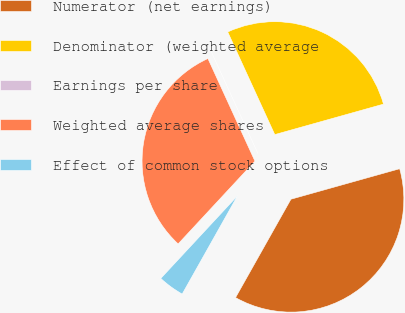<chart> <loc_0><loc_0><loc_500><loc_500><pie_chart><fcel>Numerator (net earnings)<fcel>Denominator (weighted average<fcel>Earnings per share<fcel>Weighted average shares<fcel>Effect of common stock options<nl><fcel>37.51%<fcel>27.49%<fcel>0.0%<fcel>31.25%<fcel>3.75%<nl></chart> 